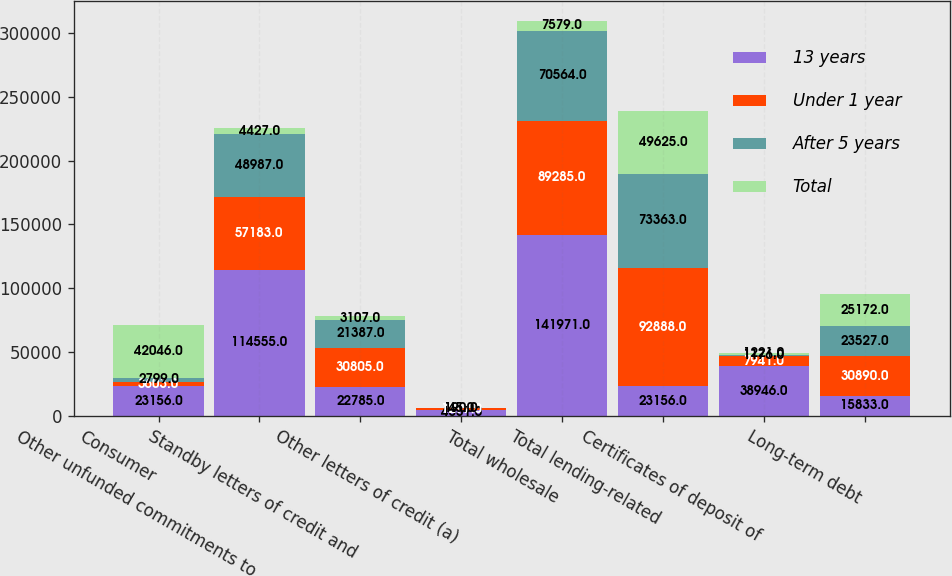Convert chart to OTSL. <chart><loc_0><loc_0><loc_500><loc_500><stacked_bar_chart><ecel><fcel>Consumer<fcel>Other unfunded commitments to<fcel>Standby letters of credit and<fcel>Other letters of credit (a)<fcel>Total wholesale<fcel>Total lending-related<fcel>Certificates of deposit of<fcel>Long-term debt<nl><fcel>13 years<fcel>23156<fcel>114555<fcel>22785<fcel>4631<fcel>141971<fcel>23156<fcel>38946<fcel>15833<nl><fcel>Under 1 year<fcel>3603<fcel>57183<fcel>30805<fcel>1297<fcel>89285<fcel>92888<fcel>7941<fcel>30890<nl><fcel>After 5 years<fcel>2799<fcel>48987<fcel>21387<fcel>190<fcel>70564<fcel>73363<fcel>1176<fcel>23527<nl><fcel>Total<fcel>42046<fcel>4427<fcel>3107<fcel>45<fcel>7579<fcel>49625<fcel>1221<fcel>25172<nl></chart> 